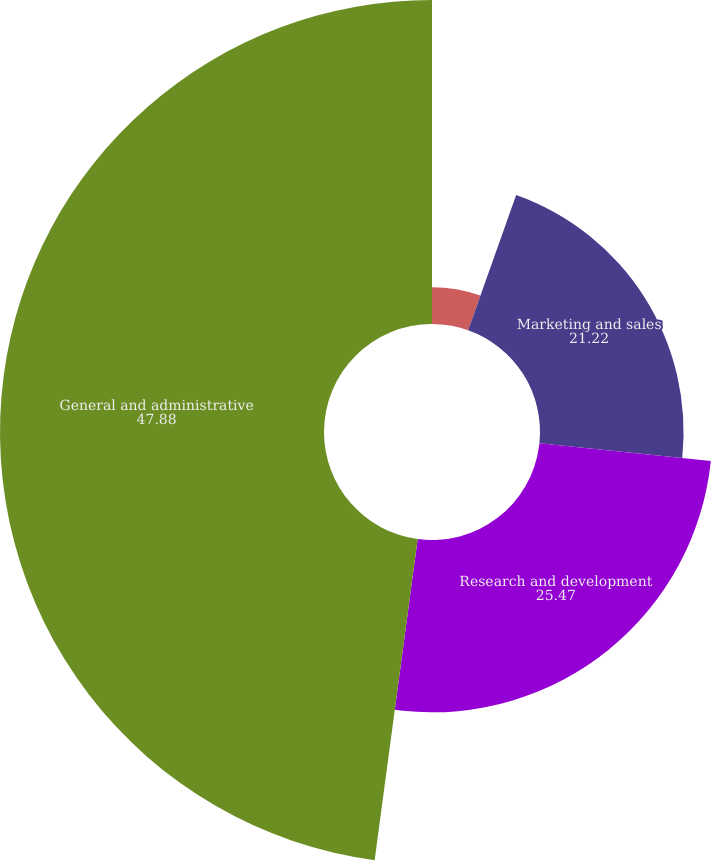<chart> <loc_0><loc_0><loc_500><loc_500><pie_chart><fcel>Cost of license and other<fcel>Marketing and sales<fcel>Research and development<fcel>General and administrative<nl><fcel>5.43%<fcel>21.22%<fcel>25.47%<fcel>47.88%<nl></chart> 